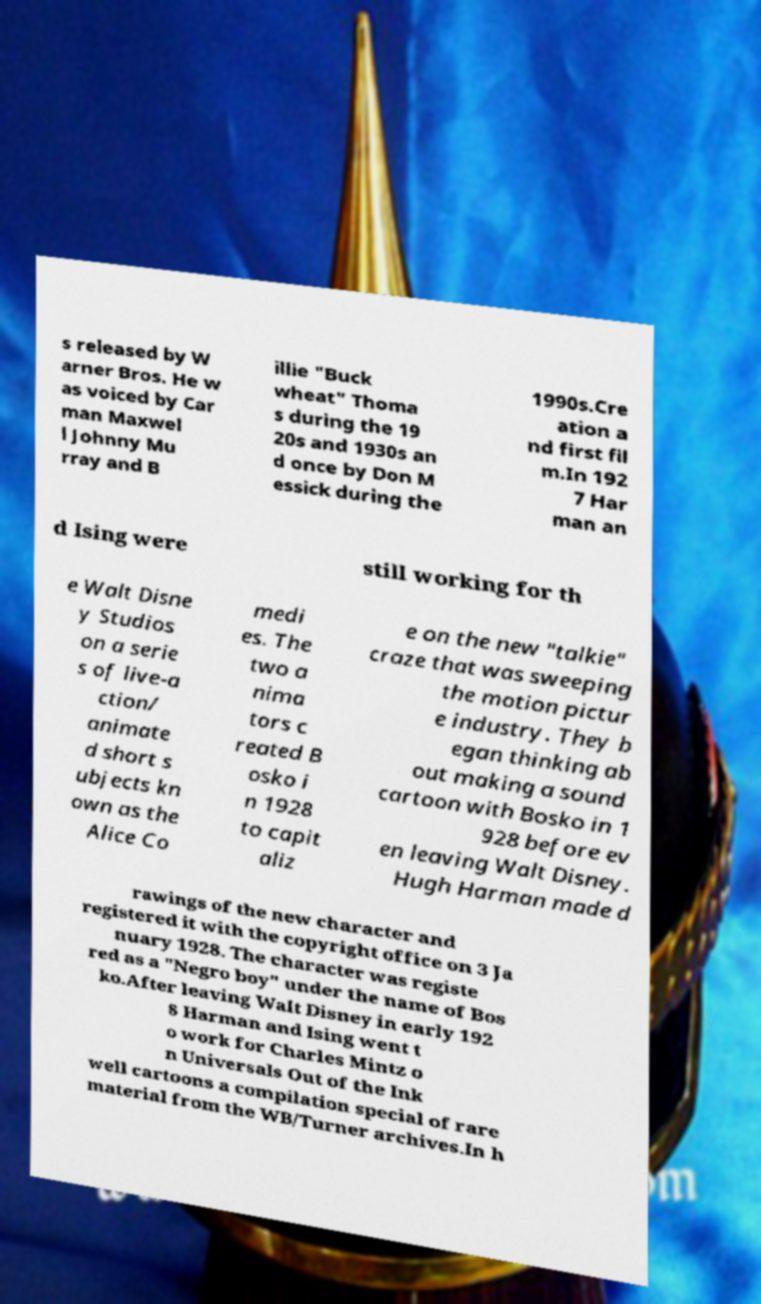Can you accurately transcribe the text from the provided image for me? s released by W arner Bros. He w as voiced by Car man Maxwel l Johnny Mu rray and B illie "Buck wheat" Thoma s during the 19 20s and 1930s an d once by Don M essick during the 1990s.Cre ation a nd first fil m.In 192 7 Har man an d Ising were still working for th e Walt Disne y Studios on a serie s of live-a ction/ animate d short s ubjects kn own as the Alice Co medi es. The two a nima tors c reated B osko i n 1928 to capit aliz e on the new "talkie" craze that was sweeping the motion pictur e industry. They b egan thinking ab out making a sound cartoon with Bosko in 1 928 before ev en leaving Walt Disney. Hugh Harman made d rawings of the new character and registered it with the copyright office on 3 Ja nuary 1928. The character was registe red as a "Negro boy" under the name of Bos ko.After leaving Walt Disney in early 192 8 Harman and Ising went t o work for Charles Mintz o n Universals Out of the Ink well cartoons a compilation special of rare material from the WB/Turner archives.In h 